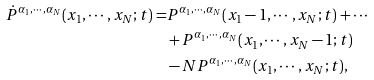<formula> <loc_0><loc_0><loc_500><loc_500>\dot { P } ^ { \alpha _ { 1 } , \cdots , \alpha _ { N } } ( x _ { 1 } , \cdots , x _ { N } ; t ) = & P ^ { \alpha _ { 1 } , \cdots , \alpha _ { N } } ( x _ { 1 } - 1 , \cdots , x _ { N } ; t ) + \cdots \\ & + P ^ { \alpha _ { 1 } , \cdots , \alpha _ { N } } ( x _ { 1 } , \cdots , x _ { N } - 1 ; t ) \\ & - N P ^ { \alpha _ { 1 } , \cdots , \alpha _ { N } } ( x _ { 1 } , \cdots , x _ { N } ; t ) ,</formula> 